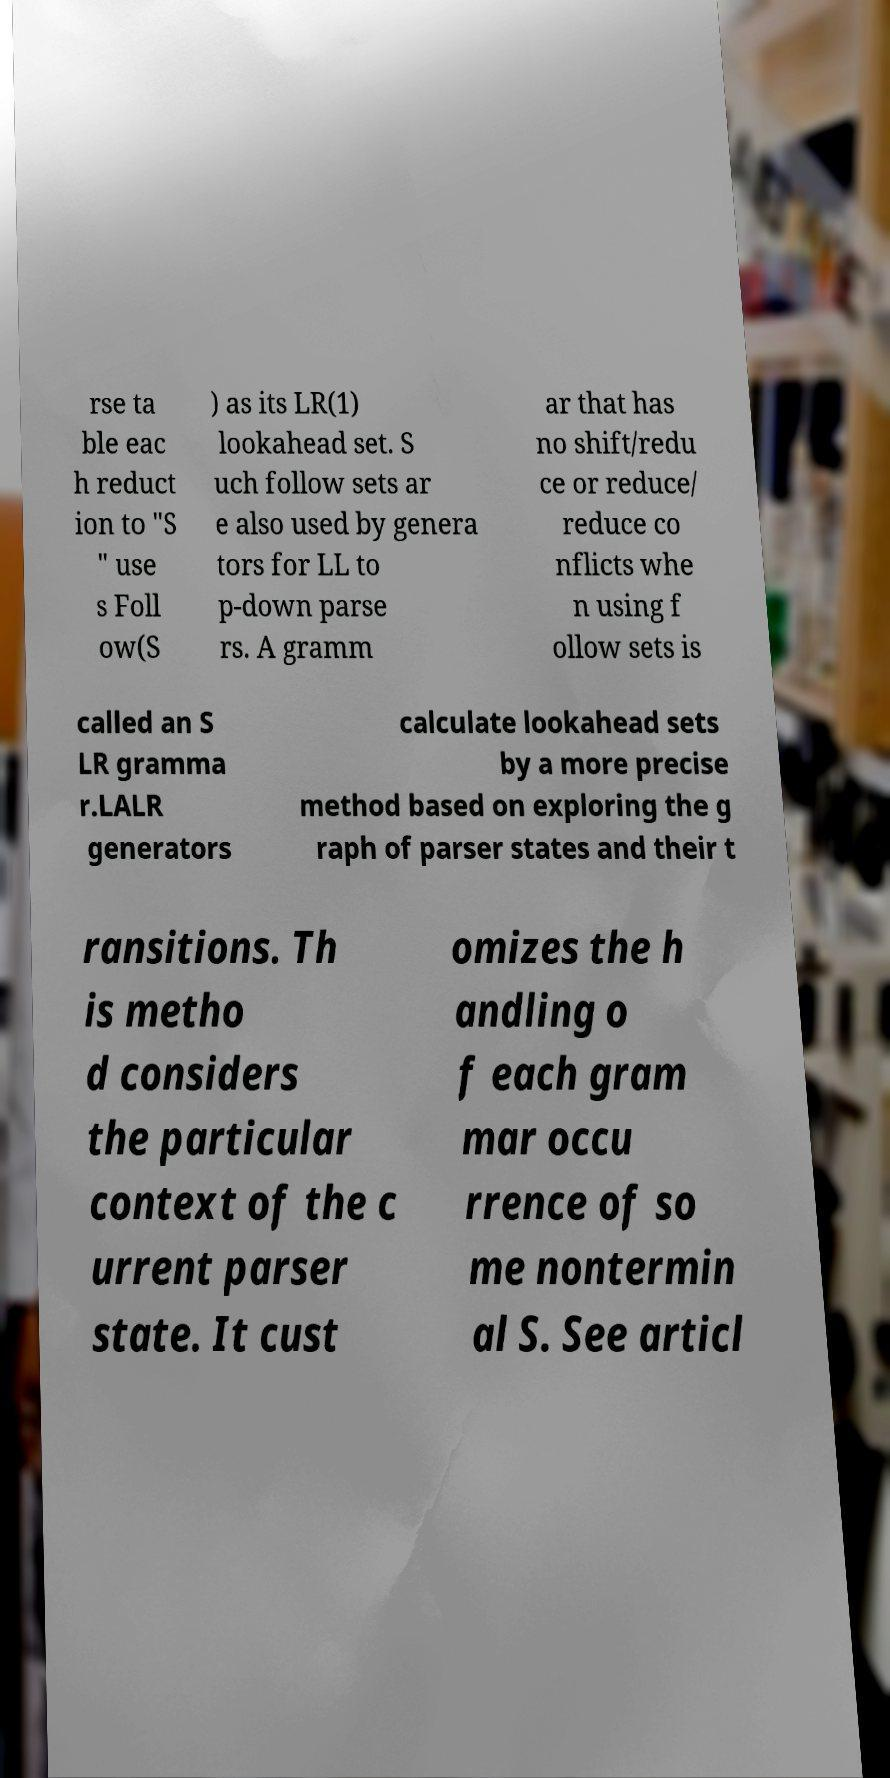I need the written content from this picture converted into text. Can you do that? rse ta ble eac h reduct ion to "S " use s Foll ow(S ) as its LR(1) lookahead set. S uch follow sets ar e also used by genera tors for LL to p-down parse rs. A gramm ar that has no shift/redu ce or reduce/ reduce co nflicts whe n using f ollow sets is called an S LR gramma r.LALR generators calculate lookahead sets by a more precise method based on exploring the g raph of parser states and their t ransitions. Th is metho d considers the particular context of the c urrent parser state. It cust omizes the h andling o f each gram mar occu rrence of so me nontermin al S. See articl 